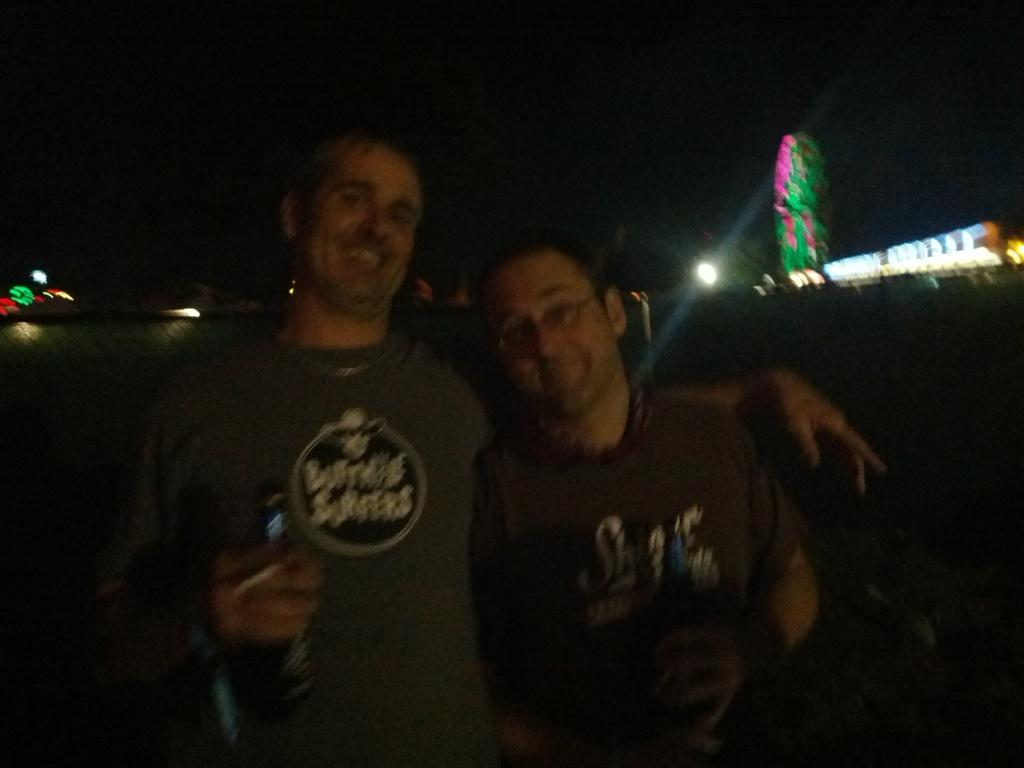How many people are in the image? There are two persons in the image. What are the people wearing? Both persons are wearing clothes. What type of bridge can be seen in the image? There is no bridge present in the image. Who is the manager of the people in the image? There is no indication of a manager or any hierarchical relationship between the two persons in the image. 